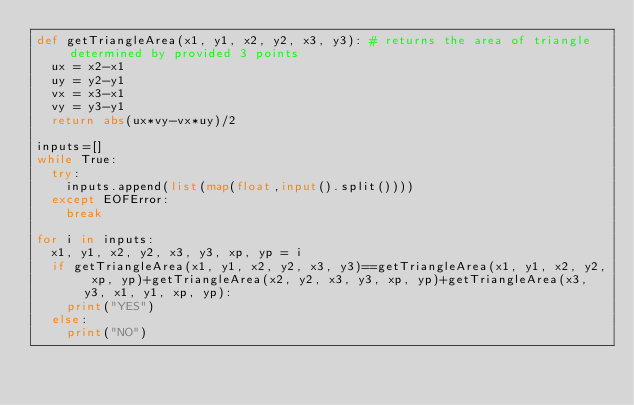Convert code to text. <code><loc_0><loc_0><loc_500><loc_500><_Python_>def getTriangleArea(x1, y1, x2, y2, x3, y3): # returns the area of triangle determined by provided 3 points
  ux = x2-x1
  uy = y2-y1
  vx = x3-x1
  vy = y3-y1
  return abs(ux*vy-vx*uy)/2

inputs=[]
while True:
  try:
    inputs.append(list(map(float,input().split())))
  except EOFError:
    break

for i in inputs:
  x1, y1, x2, y2, x3, y3, xp, yp = i
  if getTriangleArea(x1, y1, x2, y2, x3, y3)==getTriangleArea(x1, y1, x2, y2, xp, yp)+getTriangleArea(x2, y2, x3, y3, xp, yp)+getTriangleArea(x3, y3, x1, y1, xp, yp):
    print("YES")
  else:
    print("NO")</code> 